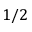<formula> <loc_0><loc_0><loc_500><loc_500>1 / 2</formula> 